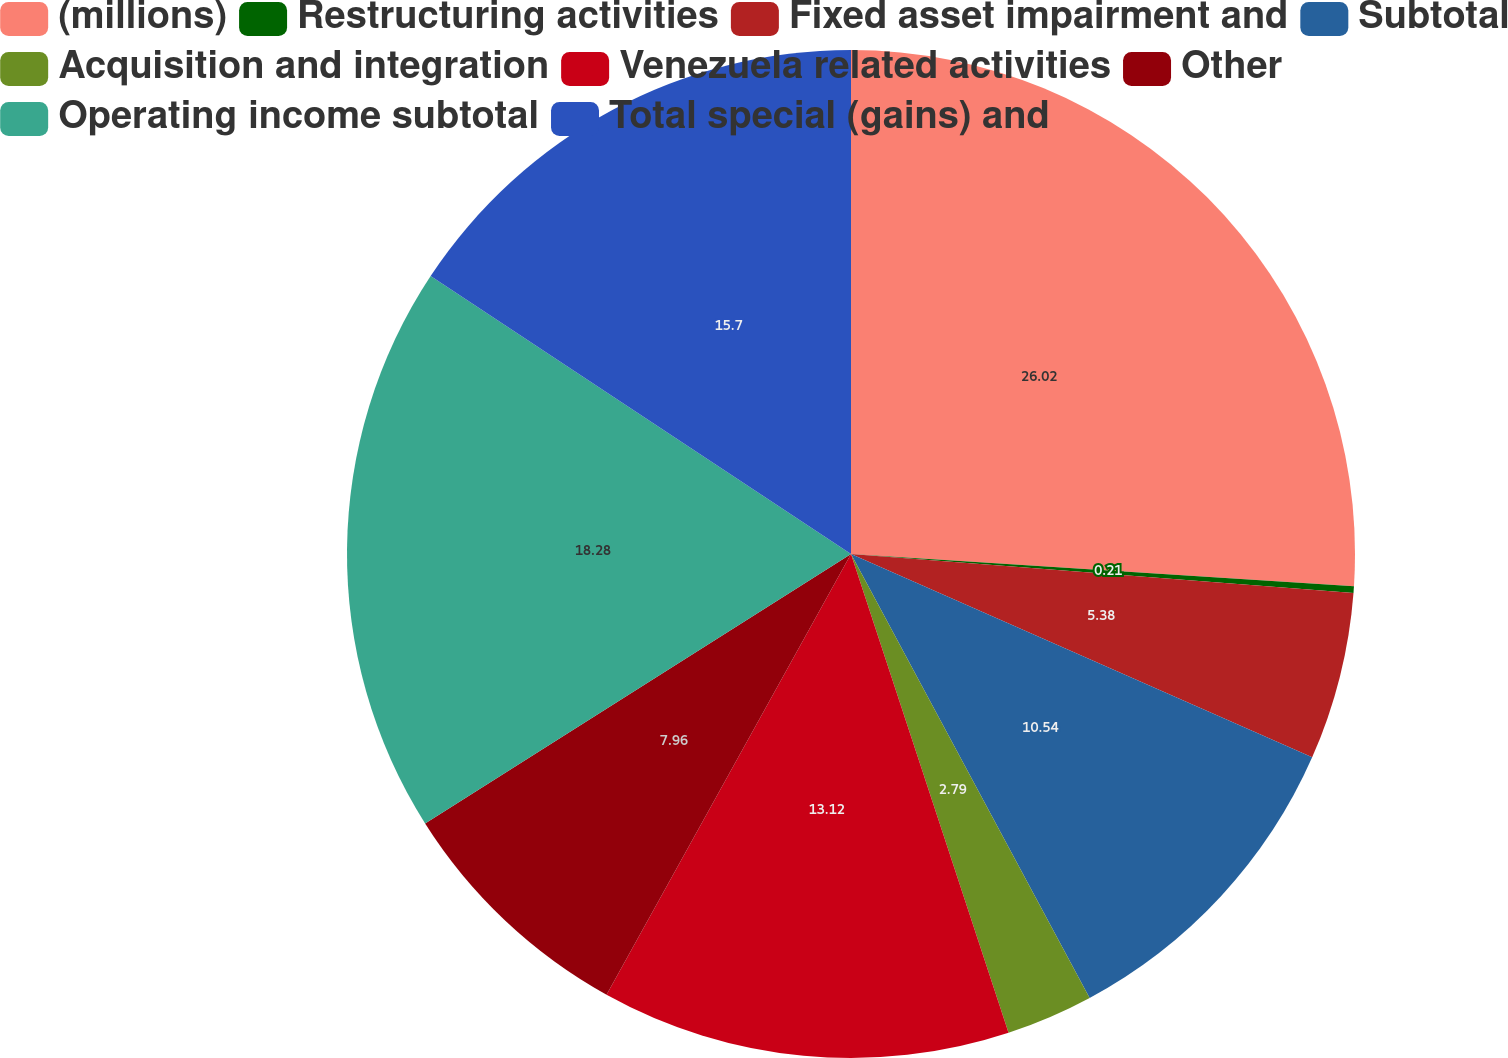Convert chart. <chart><loc_0><loc_0><loc_500><loc_500><pie_chart><fcel>(millions)<fcel>Restructuring activities<fcel>Fixed asset impairment and<fcel>Subtotal<fcel>Acquisition and integration<fcel>Venezuela related activities<fcel>Other<fcel>Operating income subtotal<fcel>Total special (gains) and<nl><fcel>26.02%<fcel>0.21%<fcel>5.38%<fcel>10.54%<fcel>2.79%<fcel>13.12%<fcel>7.96%<fcel>18.28%<fcel>15.7%<nl></chart> 